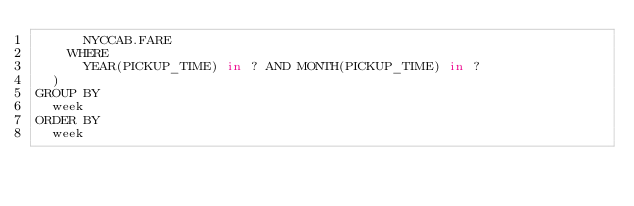Convert code to text. <code><loc_0><loc_0><loc_500><loc_500><_SQL_>			NYCCAB.FARE
		WHERE
			YEAR(PICKUP_TIME) in ? AND MONTH(PICKUP_TIME) in ?
	)
GROUP BY
 	week
ORDER BY
 	week
</code> 